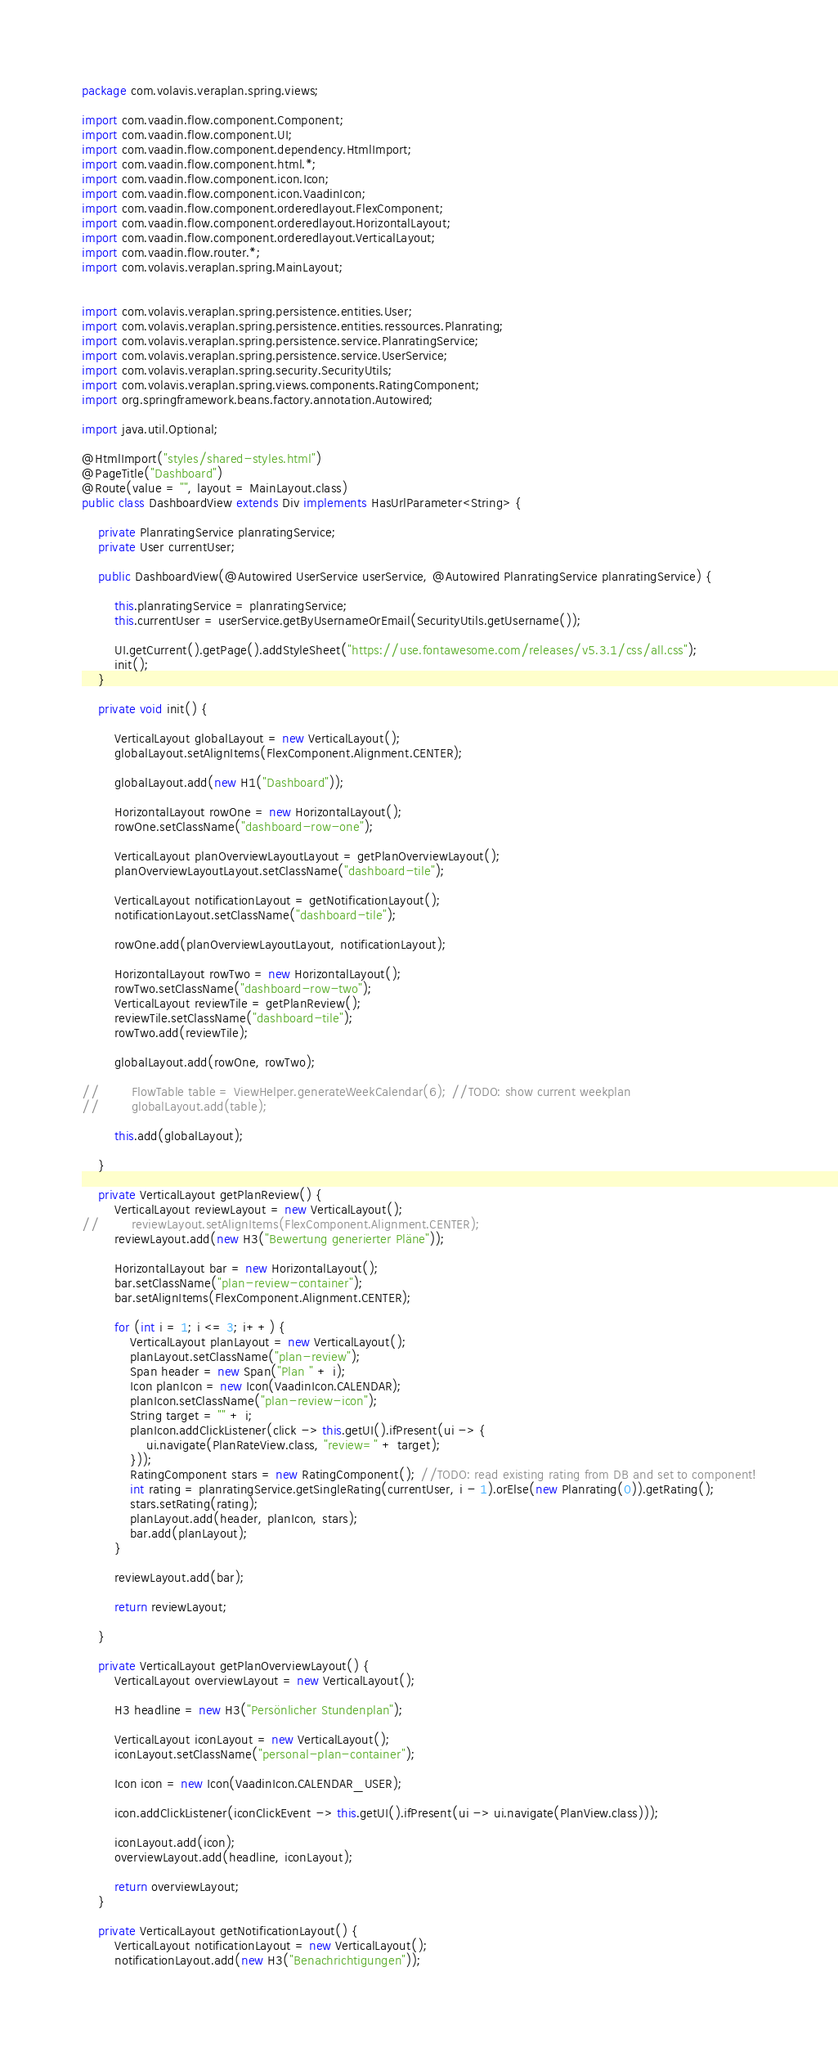Convert code to text. <code><loc_0><loc_0><loc_500><loc_500><_Java_>package com.volavis.veraplan.spring.views;

import com.vaadin.flow.component.Component;
import com.vaadin.flow.component.UI;
import com.vaadin.flow.component.dependency.HtmlImport;
import com.vaadin.flow.component.html.*;
import com.vaadin.flow.component.icon.Icon;
import com.vaadin.flow.component.icon.VaadinIcon;
import com.vaadin.flow.component.orderedlayout.FlexComponent;
import com.vaadin.flow.component.orderedlayout.HorizontalLayout;
import com.vaadin.flow.component.orderedlayout.VerticalLayout;
import com.vaadin.flow.router.*;
import com.volavis.veraplan.spring.MainLayout;


import com.volavis.veraplan.spring.persistence.entities.User;
import com.volavis.veraplan.spring.persistence.entities.ressources.Planrating;
import com.volavis.veraplan.spring.persistence.service.PlanratingService;
import com.volavis.veraplan.spring.persistence.service.UserService;
import com.volavis.veraplan.spring.security.SecurityUtils;
import com.volavis.veraplan.spring.views.components.RatingComponent;
import org.springframework.beans.factory.annotation.Autowired;

import java.util.Optional;

@HtmlImport("styles/shared-styles.html")
@PageTitle("Dashboard")
@Route(value = "", layout = MainLayout.class)
public class DashboardView extends Div implements HasUrlParameter<String> {

    private PlanratingService planratingService;
    private User currentUser;

    public DashboardView(@Autowired UserService userService, @Autowired PlanratingService planratingService) {

        this.planratingService = planratingService;
        this.currentUser = userService.getByUsernameOrEmail(SecurityUtils.getUsername());

        UI.getCurrent().getPage().addStyleSheet("https://use.fontawesome.com/releases/v5.3.1/css/all.css");
        init();
    }

    private void init() {

        VerticalLayout globalLayout = new VerticalLayout();
        globalLayout.setAlignItems(FlexComponent.Alignment.CENTER);

        globalLayout.add(new H1("Dashboard"));

        HorizontalLayout rowOne = new HorizontalLayout();
        rowOne.setClassName("dashboard-row-one");

        VerticalLayout planOverviewLayoutLayout = getPlanOverviewLayout();
        planOverviewLayoutLayout.setClassName("dashboard-tile");

        VerticalLayout notificationLayout = getNotificationLayout();
        notificationLayout.setClassName("dashboard-tile");

        rowOne.add(planOverviewLayoutLayout, notificationLayout);

        HorizontalLayout rowTwo = new HorizontalLayout();
        rowTwo.setClassName("dashboard-row-two");
        VerticalLayout reviewTile = getPlanReview();
        reviewTile.setClassName("dashboard-tile");
        rowTwo.add(reviewTile);

        globalLayout.add(rowOne, rowTwo);

//        FlowTable table = ViewHelper.generateWeekCalendar(6); //TODO: show current weekplan
//        globalLayout.add(table);

        this.add(globalLayout);

    }

    private VerticalLayout getPlanReview() {
        VerticalLayout reviewLayout = new VerticalLayout();
//        reviewLayout.setAlignItems(FlexComponent.Alignment.CENTER);
        reviewLayout.add(new H3("Bewertung generierter Pläne"));

        HorizontalLayout bar = new HorizontalLayout();
        bar.setClassName("plan-review-container");
        bar.setAlignItems(FlexComponent.Alignment.CENTER);

        for (int i = 1; i <= 3; i++) {
            VerticalLayout planLayout = new VerticalLayout();
            planLayout.setClassName("plan-review");
            Span header = new Span("Plan " + i);
            Icon planIcon = new Icon(VaadinIcon.CALENDAR);
            planIcon.setClassName("plan-review-icon");
            String target = "" + i;
            planIcon.addClickListener(click -> this.getUI().ifPresent(ui -> {
                ui.navigate(PlanRateView.class, "review=" + target);
            }));
            RatingComponent stars = new RatingComponent(); //TODO: read existing rating from DB and set to component!
            int rating = planratingService.getSingleRating(currentUser, i - 1).orElse(new Planrating(0)).getRating();
            stars.setRating(rating);
            planLayout.add(header, planIcon, stars);
            bar.add(planLayout);
        }

        reviewLayout.add(bar);

        return reviewLayout;

    }

    private VerticalLayout getPlanOverviewLayout() {
        VerticalLayout overviewLayout = new VerticalLayout();

        H3 headline = new H3("Persönlicher Stundenplan");

        VerticalLayout iconLayout = new VerticalLayout();
        iconLayout.setClassName("personal-plan-container");

        Icon icon = new Icon(VaadinIcon.CALENDAR_USER);

        icon.addClickListener(iconClickEvent -> this.getUI().ifPresent(ui -> ui.navigate(PlanView.class)));

        iconLayout.add(icon);
        overviewLayout.add(headline, iconLayout);

        return overviewLayout;
    }

    private VerticalLayout getNotificationLayout() {
        VerticalLayout notificationLayout = new VerticalLayout();
        notificationLayout.add(new H3("Benachrichtigungen"));</code> 